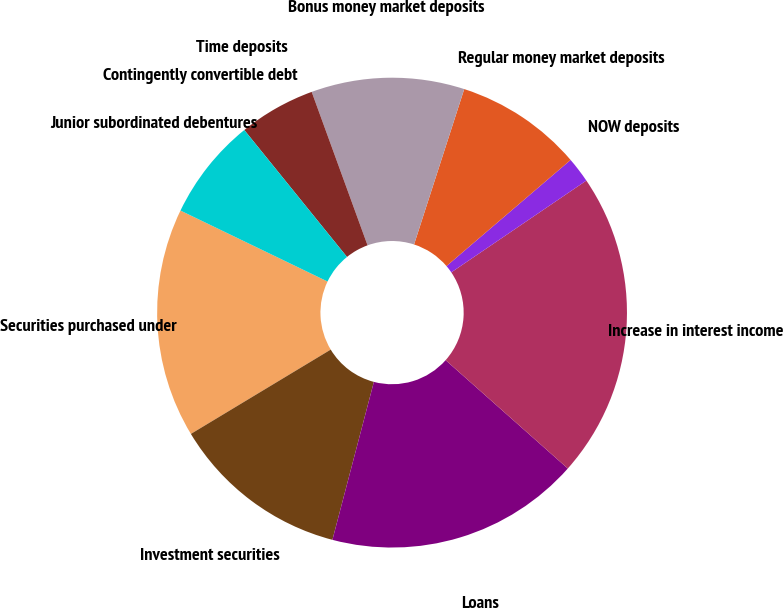Convert chart. <chart><loc_0><loc_0><loc_500><loc_500><pie_chart><fcel>Securities purchased under<fcel>Investment securities<fcel>Loans<fcel>Increase in interest income<fcel>NOW deposits<fcel>Regular money market deposits<fcel>Bonus money market deposits<fcel>Time deposits<fcel>Contingently convertible debt<fcel>Junior subordinated debentures<nl><fcel>15.79%<fcel>12.28%<fcel>17.54%<fcel>21.05%<fcel>1.76%<fcel>8.77%<fcel>10.53%<fcel>5.27%<fcel>0.0%<fcel>7.02%<nl></chart> 